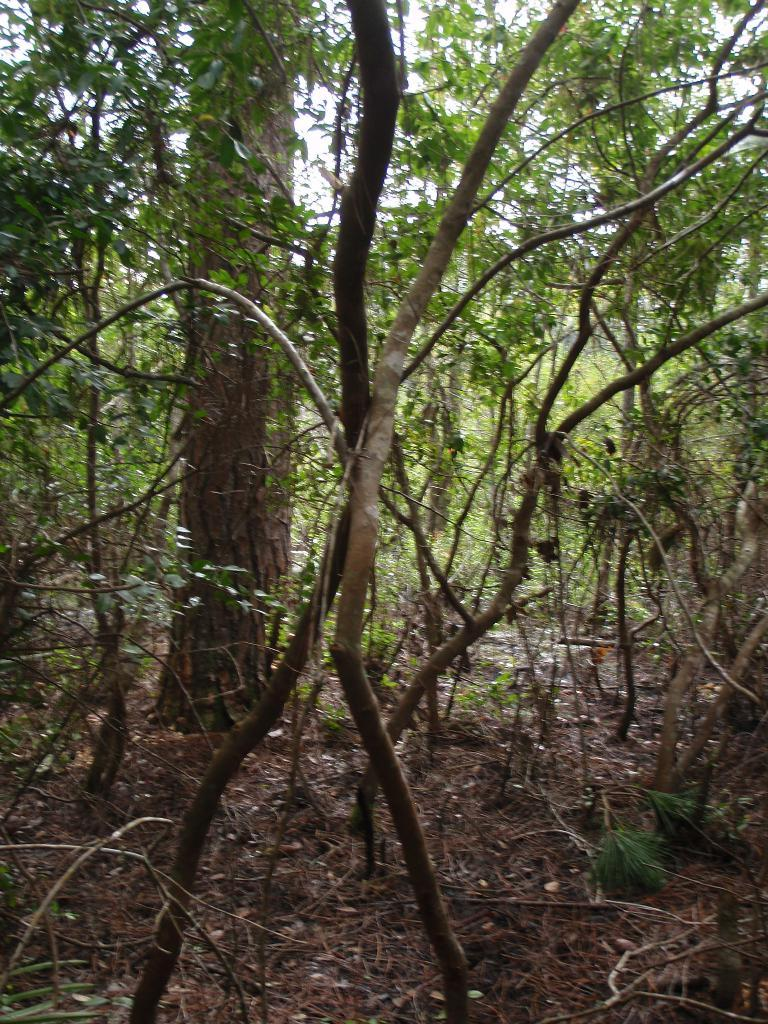What type of vegetation is present in the image? There are many trees in the image. Where can grass be seen in the image? Grass is visible in the bottom left of the image. What part of the natural environment is visible in the image? The sky is visible at the top of the image. What type of committee is responsible for maintaining the boundary in the image? There is no committee or boundary present in the image; it features trees and grass. What type of rod can be seen in the image? There is no rod present in the image. 